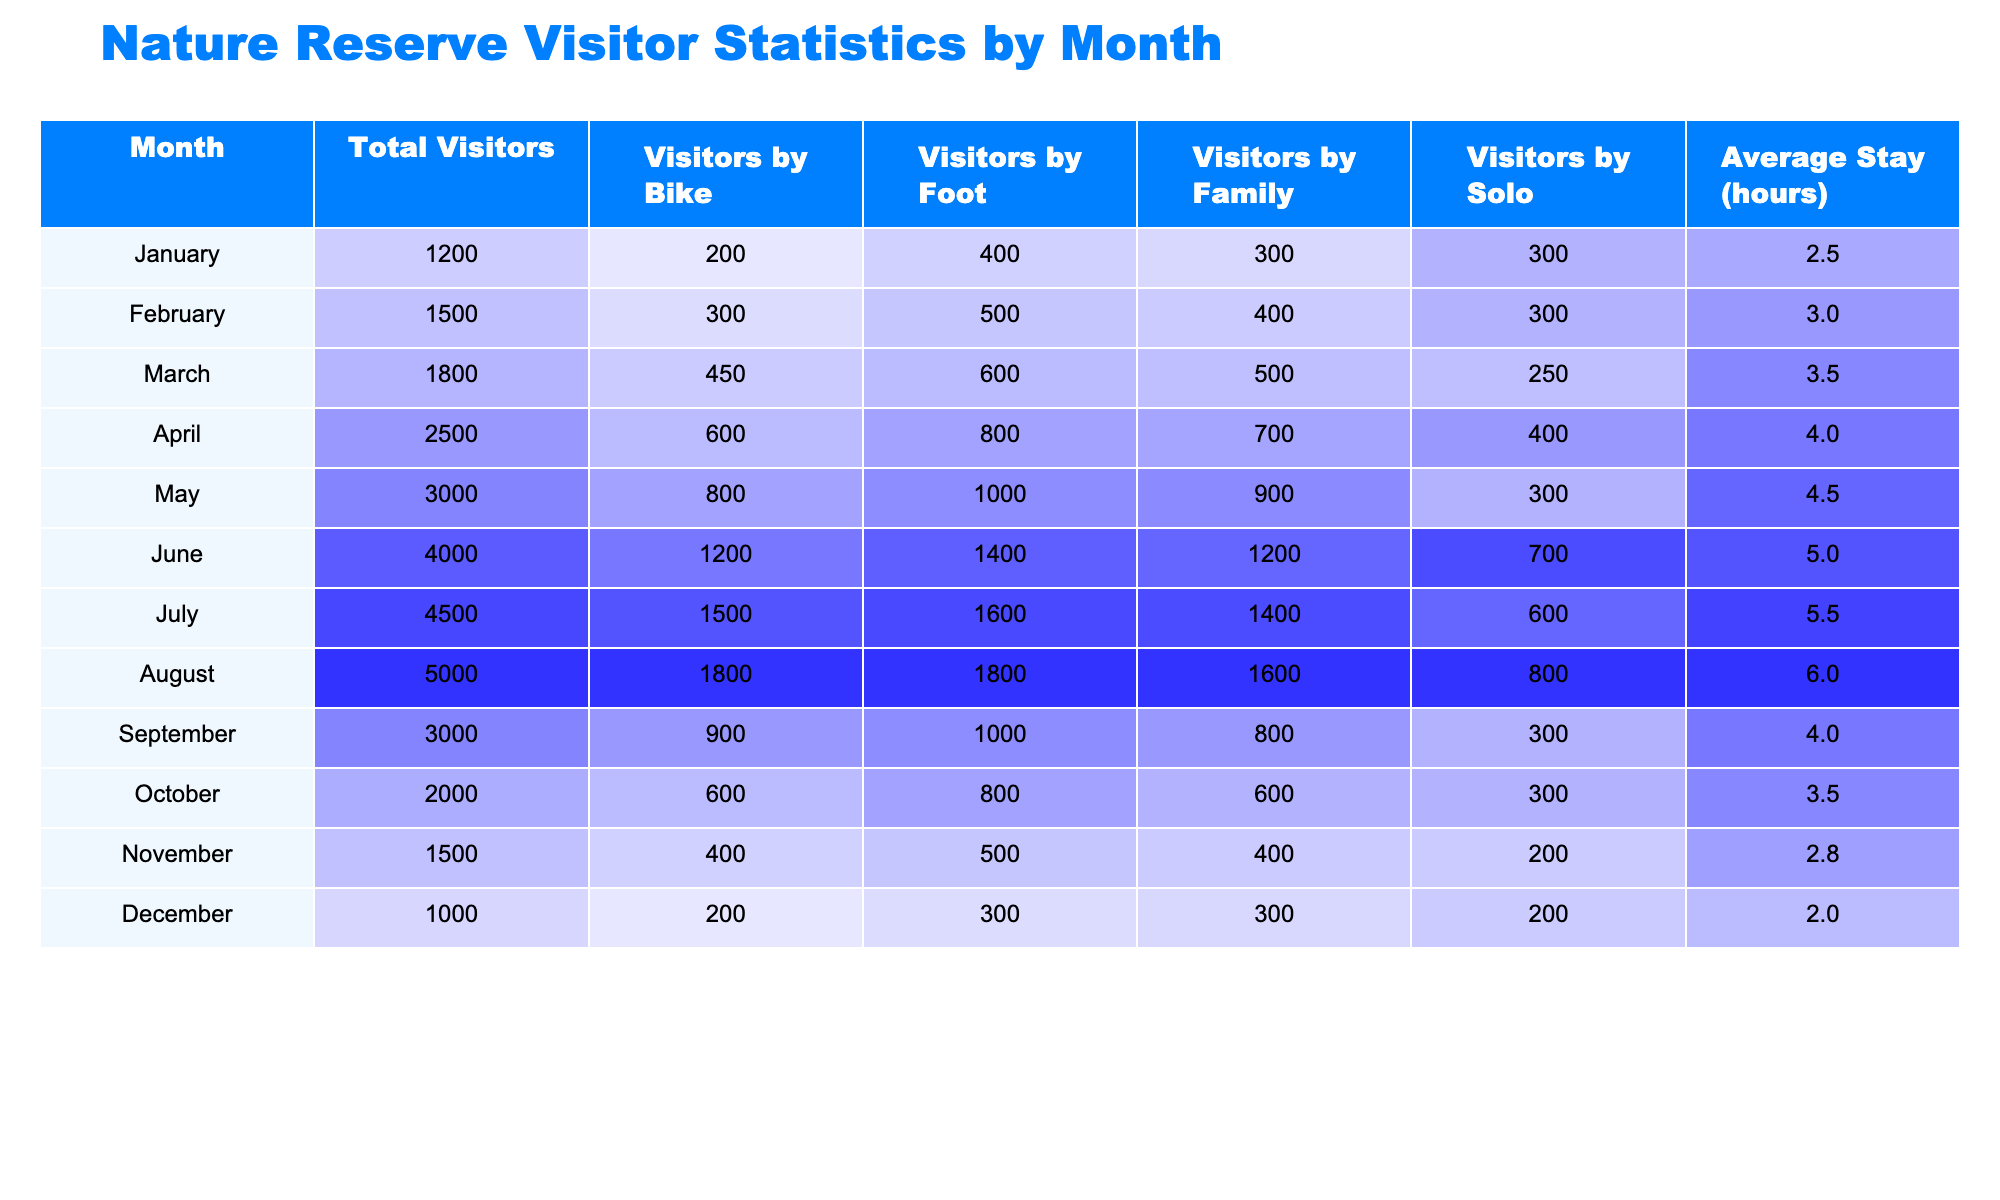What month had the highest total visitors? Looking at the "Total Visitors" column, July has the highest value with 4500 visitors.
Answer: July How many visitors came by bike in June? In June, the "Visitors by Bike" column shows the value of 1200 visitors.
Answer: 1200 What is the average stay in April? In the "Average Stay (hours)" column for April, the value is 4.0 hours.
Answer: 4.0 hours What month had the least visitors by foot? By examining the "Visitors by Foot" column, December has the lowest value of 300 visitors.
Answer: December What is the total number of solo visitors from January to April? By summing the "Visitors by Solo" values for January (300), February (300), March (250), and April (400), the total is 300 + 300 + 250 + 400 = 1250.
Answer: 1250 How many more visitors came by foot in August compared to October? The "Visitors by Foot" for August is 1800 and for October is 800. The difference is 1800 - 800 = 1000.
Answer: 1000 Is the average stay in November longer than in January? The average stay in November is 2.8 hours and in January, it’s 2.5 hours; since 2.8 > 2.5, the statement is true.
Answer: Yes In which month did the visitors by bike reach 1500? Directly from the "Visitors by Bike" column, we see that July has this value of 1500 visitors.
Answer: July What is the average number of total visitors per month? The total visitors from all months is 1200 + 1500 + 1800 + 2500 + 3000 + 4000 + 4500 + 5000 + 3000 + 2000 + 1500 + 1000 = 24700. Dividing by 12 months gives 24700/12 ≈ 2058.33.
Answer: 2058.33 Which category had the highest visitor count in June? In June, the highest value in the visitor categories is "Visitors by Bike" with 1200 visitors compared to other categories.
Answer: Visitors by Bike In which month did solo visitors outnumber family visitors? In March, the "Visitors by Solo" showed 250, while "Visitors by Family" had 500; this means family visitors outnumber solo visitors. By checking April, solo visitors are 400 and family visitors are 700, again family outnumbers solo. However, in August, solo (800) outnumber family (1600), thus no month has solo outnumbering.
Answer: No month 